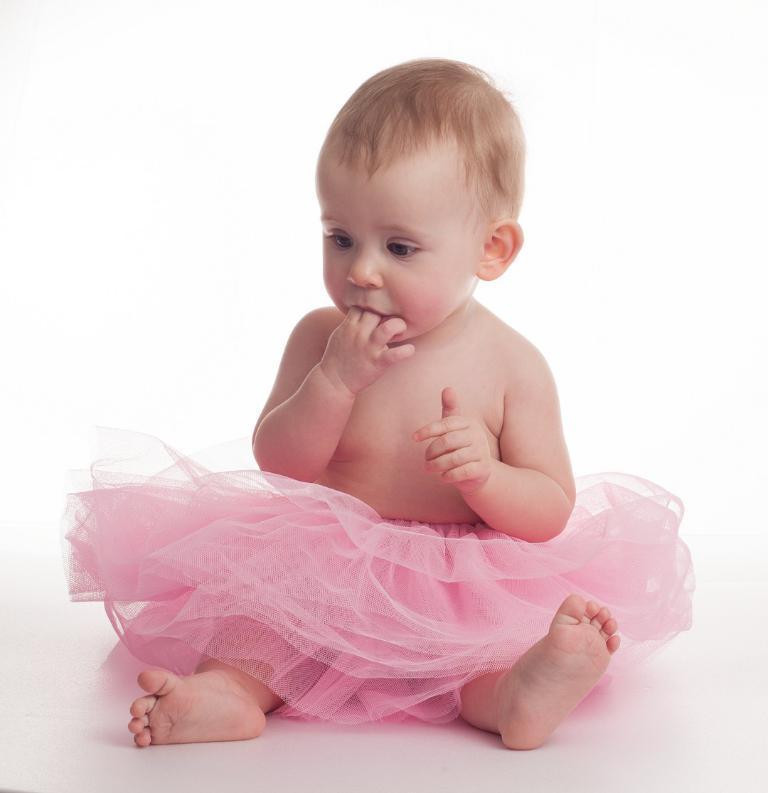Can you describe this image briefly? In this image, I can see a baby sitting. This baby wore a skirt, which is light pink in color. The background looks white in color. 